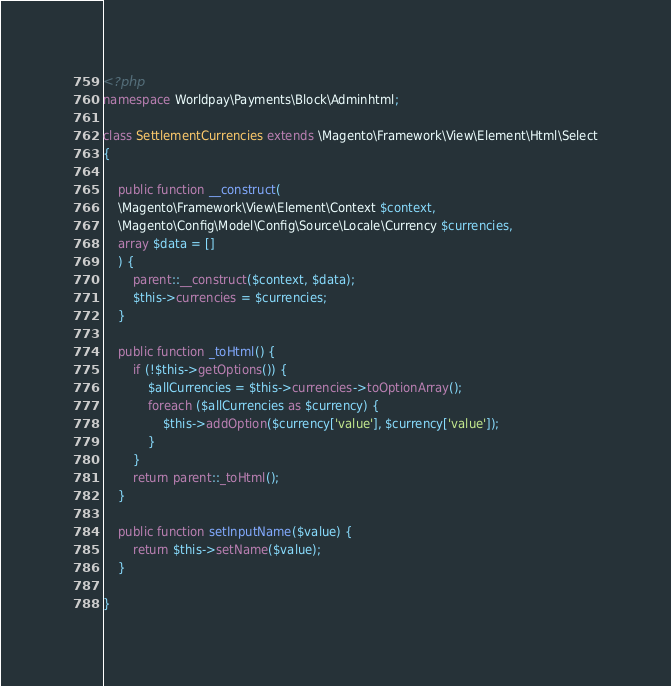<code> <loc_0><loc_0><loc_500><loc_500><_PHP_><?php
namespace Worldpay\Payments\Block\Adminhtml;

class SettlementCurrencies extends \Magento\Framework\View\Element\Html\Select
{

	public function __construct(
    \Magento\Framework\View\Element\Context $context, 
    \Magento\Config\Model\Config\Source\Locale\Currency $currencies, 
    array $data = []
    ) {
        parent::__construct($context, $data);
        $this->currencies = $currencies;
    }

    public function _toHtml() {
        if (!$this->getOptions()) {
            $allCurrencies = $this->currencies->toOptionArray();
            foreach ($allCurrencies as $currency) {
            	$this->addOption($currency['value'], $currency['value']);
            }
        }
        return parent::_toHtml();
    }

    public function setInputName($value) {
        return $this->setName($value);
    }

}</code> 